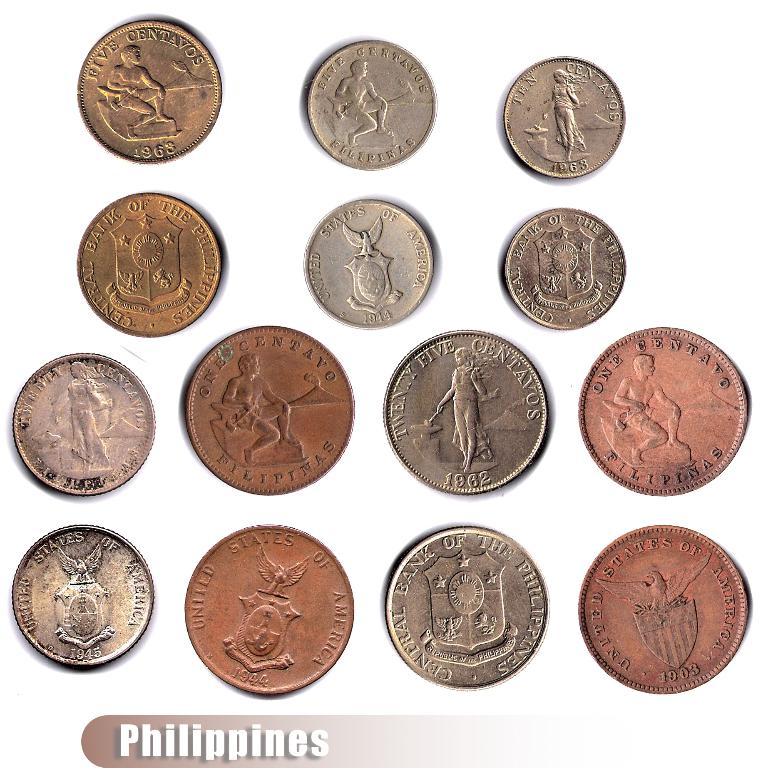Is this a philippine currency?
Give a very brief answer. Yes. 